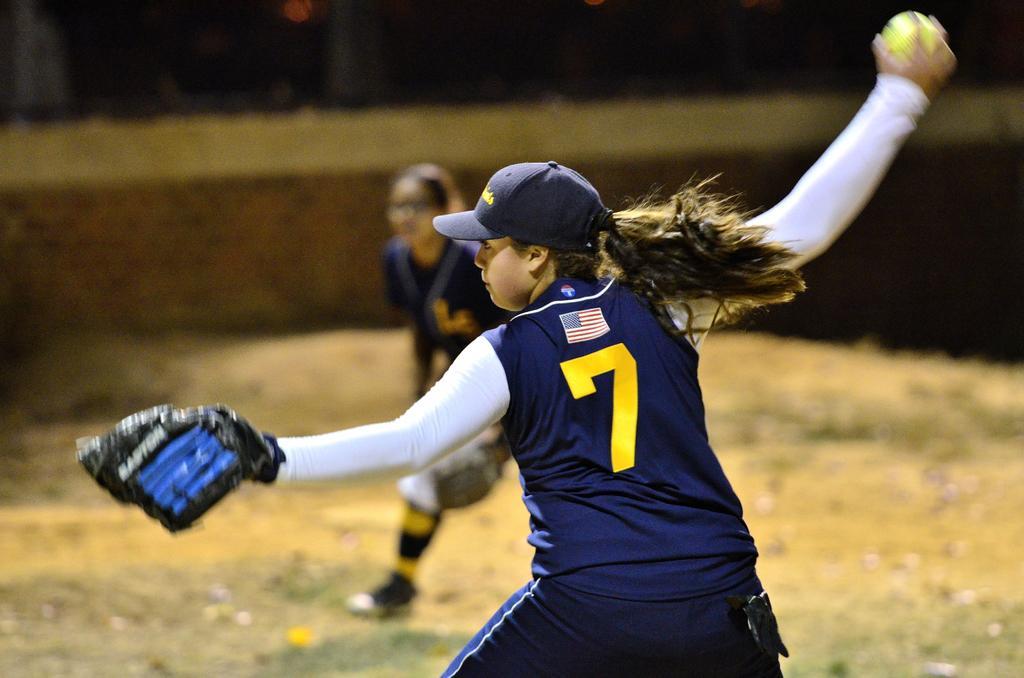How would you summarize this image in a sentence or two? In the foreground of this image, there is a woman standing and wearing gloves to one hand and holding a ball in the other hand. In the background, there is another woman standing on the ground. 